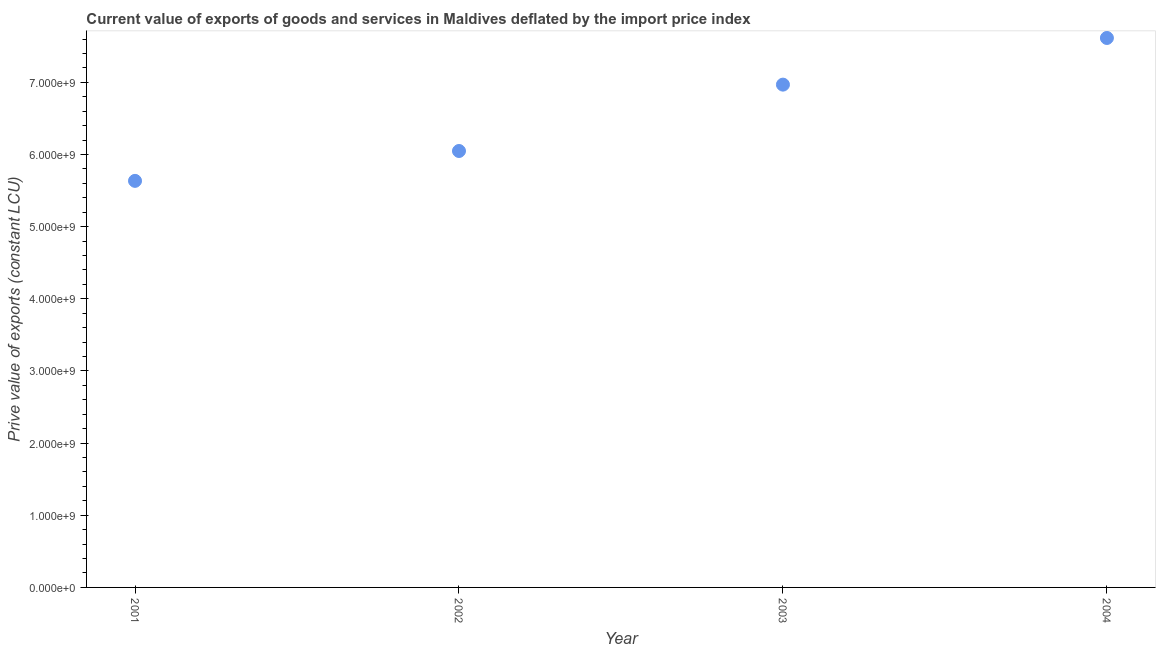What is the price value of exports in 2002?
Offer a terse response. 6.05e+09. Across all years, what is the maximum price value of exports?
Keep it short and to the point. 7.61e+09. Across all years, what is the minimum price value of exports?
Provide a short and direct response. 5.63e+09. In which year was the price value of exports maximum?
Your answer should be compact. 2004. What is the sum of the price value of exports?
Provide a succinct answer. 2.63e+1. What is the difference between the price value of exports in 2003 and 2004?
Your response must be concise. -6.47e+08. What is the average price value of exports per year?
Keep it short and to the point. 6.57e+09. What is the median price value of exports?
Your answer should be compact. 6.51e+09. In how many years, is the price value of exports greater than 800000000 LCU?
Offer a very short reply. 4. What is the ratio of the price value of exports in 2003 to that in 2004?
Offer a very short reply. 0.92. Is the price value of exports in 2001 less than that in 2002?
Make the answer very short. Yes. Is the difference between the price value of exports in 2001 and 2004 greater than the difference between any two years?
Provide a succinct answer. Yes. What is the difference between the highest and the second highest price value of exports?
Your answer should be very brief. 6.47e+08. Is the sum of the price value of exports in 2002 and 2004 greater than the maximum price value of exports across all years?
Make the answer very short. Yes. What is the difference between the highest and the lowest price value of exports?
Your answer should be very brief. 1.98e+09. In how many years, is the price value of exports greater than the average price value of exports taken over all years?
Offer a very short reply. 2. Does the price value of exports monotonically increase over the years?
Offer a very short reply. Yes. What is the difference between two consecutive major ticks on the Y-axis?
Your response must be concise. 1.00e+09. Are the values on the major ticks of Y-axis written in scientific E-notation?
Offer a very short reply. Yes. Does the graph contain any zero values?
Your response must be concise. No. What is the title of the graph?
Give a very brief answer. Current value of exports of goods and services in Maldives deflated by the import price index. What is the label or title of the X-axis?
Provide a short and direct response. Year. What is the label or title of the Y-axis?
Offer a terse response. Prive value of exports (constant LCU). What is the Prive value of exports (constant LCU) in 2001?
Your response must be concise. 5.63e+09. What is the Prive value of exports (constant LCU) in 2002?
Your answer should be very brief. 6.05e+09. What is the Prive value of exports (constant LCU) in 2003?
Make the answer very short. 6.97e+09. What is the Prive value of exports (constant LCU) in 2004?
Offer a terse response. 7.61e+09. What is the difference between the Prive value of exports (constant LCU) in 2001 and 2002?
Your response must be concise. -4.14e+08. What is the difference between the Prive value of exports (constant LCU) in 2001 and 2003?
Provide a succinct answer. -1.33e+09. What is the difference between the Prive value of exports (constant LCU) in 2001 and 2004?
Give a very brief answer. -1.98e+09. What is the difference between the Prive value of exports (constant LCU) in 2002 and 2003?
Offer a terse response. -9.20e+08. What is the difference between the Prive value of exports (constant LCU) in 2002 and 2004?
Make the answer very short. -1.57e+09. What is the difference between the Prive value of exports (constant LCU) in 2003 and 2004?
Ensure brevity in your answer.  -6.47e+08. What is the ratio of the Prive value of exports (constant LCU) in 2001 to that in 2002?
Make the answer very short. 0.93. What is the ratio of the Prive value of exports (constant LCU) in 2001 to that in 2003?
Provide a succinct answer. 0.81. What is the ratio of the Prive value of exports (constant LCU) in 2001 to that in 2004?
Provide a succinct answer. 0.74. What is the ratio of the Prive value of exports (constant LCU) in 2002 to that in 2003?
Your answer should be very brief. 0.87. What is the ratio of the Prive value of exports (constant LCU) in 2002 to that in 2004?
Ensure brevity in your answer.  0.79. What is the ratio of the Prive value of exports (constant LCU) in 2003 to that in 2004?
Your answer should be compact. 0.92. 